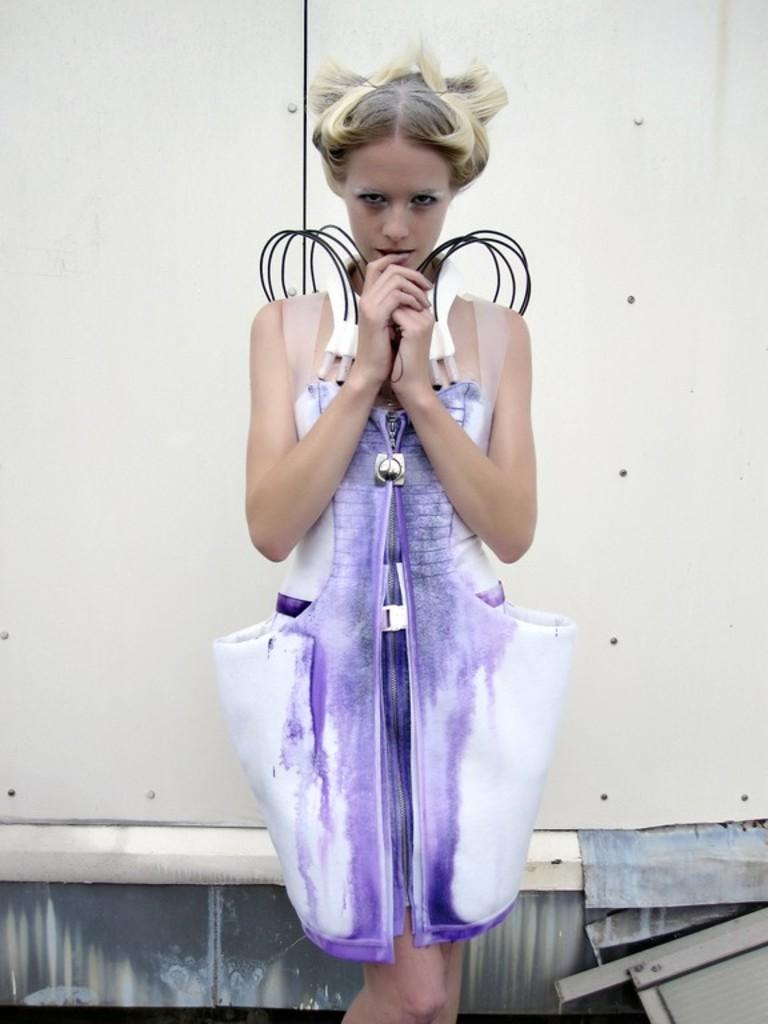Who is present in the image? There is a woman in the image. What is the woman wearing? The woman is wearing a pink dress. What is the woman doing in the image? The woman is standing. What can be seen in the background of the image? There is a wall in the background of the image. Can you tell me how much credit the woman is offering in the image? There is no mention of credit or any financial transaction in the image; it simply shows a woman standing in a pink dress with a wall in the background. 